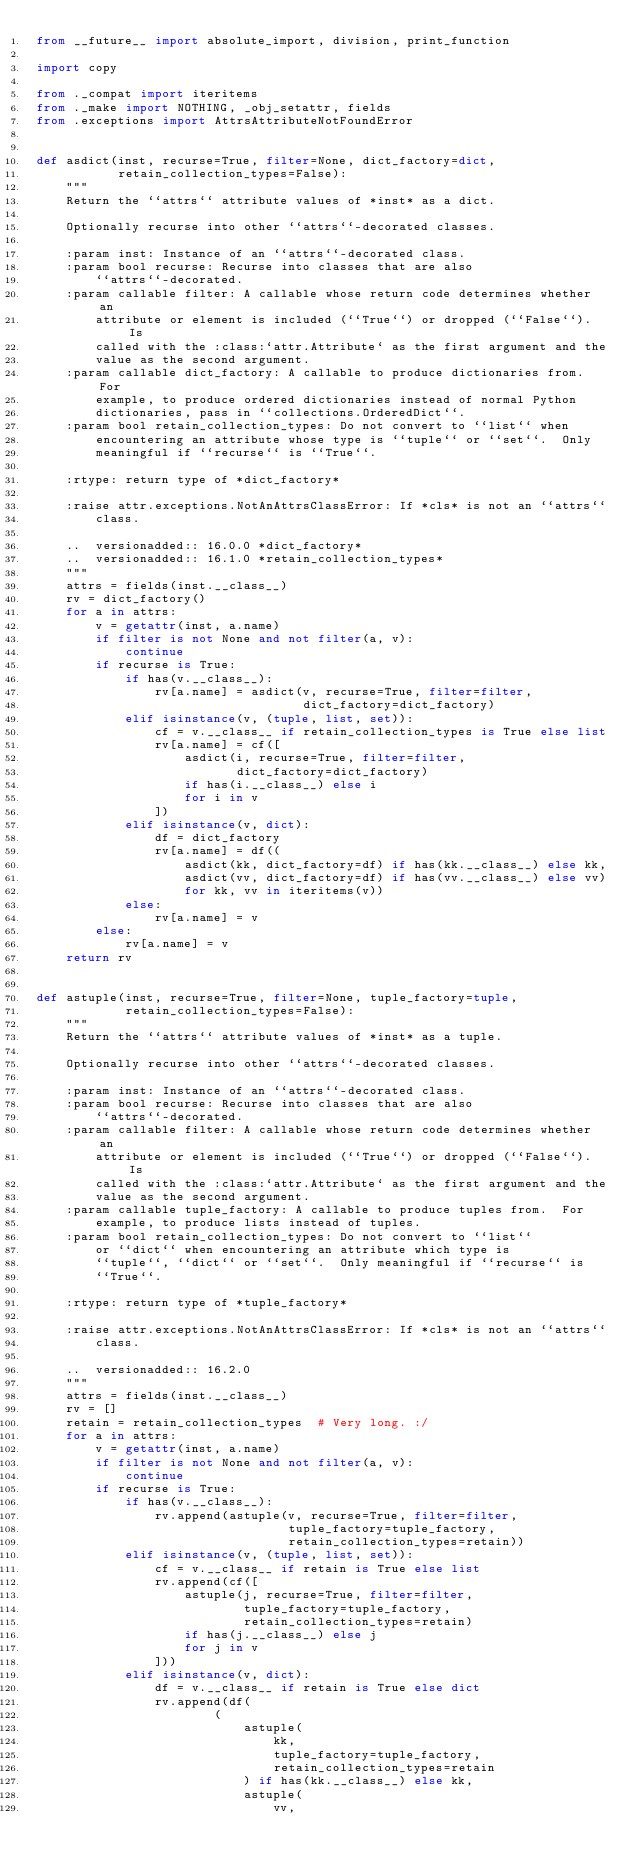<code> <loc_0><loc_0><loc_500><loc_500><_Python_>from __future__ import absolute_import, division, print_function

import copy

from ._compat import iteritems
from ._make import NOTHING, _obj_setattr, fields
from .exceptions import AttrsAttributeNotFoundError


def asdict(inst, recurse=True, filter=None, dict_factory=dict,
           retain_collection_types=False):
    """
    Return the ``attrs`` attribute values of *inst* as a dict.

    Optionally recurse into other ``attrs``-decorated classes.

    :param inst: Instance of an ``attrs``-decorated class.
    :param bool recurse: Recurse into classes that are also
        ``attrs``-decorated.
    :param callable filter: A callable whose return code determines whether an
        attribute or element is included (``True``) or dropped (``False``).  Is
        called with the :class:`attr.Attribute` as the first argument and the
        value as the second argument.
    :param callable dict_factory: A callable to produce dictionaries from.  For
        example, to produce ordered dictionaries instead of normal Python
        dictionaries, pass in ``collections.OrderedDict``.
    :param bool retain_collection_types: Do not convert to ``list`` when
        encountering an attribute whose type is ``tuple`` or ``set``.  Only
        meaningful if ``recurse`` is ``True``.

    :rtype: return type of *dict_factory*

    :raise attr.exceptions.NotAnAttrsClassError: If *cls* is not an ``attrs``
        class.

    ..  versionadded:: 16.0.0 *dict_factory*
    ..  versionadded:: 16.1.0 *retain_collection_types*
    """
    attrs = fields(inst.__class__)
    rv = dict_factory()
    for a in attrs:
        v = getattr(inst, a.name)
        if filter is not None and not filter(a, v):
            continue
        if recurse is True:
            if has(v.__class__):
                rv[a.name] = asdict(v, recurse=True, filter=filter,
                                    dict_factory=dict_factory)
            elif isinstance(v, (tuple, list, set)):
                cf = v.__class__ if retain_collection_types is True else list
                rv[a.name] = cf([
                    asdict(i, recurse=True, filter=filter,
                           dict_factory=dict_factory)
                    if has(i.__class__) else i
                    for i in v
                ])
            elif isinstance(v, dict):
                df = dict_factory
                rv[a.name] = df((
                    asdict(kk, dict_factory=df) if has(kk.__class__) else kk,
                    asdict(vv, dict_factory=df) if has(vv.__class__) else vv)
                    for kk, vv in iteritems(v))
            else:
                rv[a.name] = v
        else:
            rv[a.name] = v
    return rv


def astuple(inst, recurse=True, filter=None, tuple_factory=tuple,
            retain_collection_types=False):
    """
    Return the ``attrs`` attribute values of *inst* as a tuple.

    Optionally recurse into other ``attrs``-decorated classes.

    :param inst: Instance of an ``attrs``-decorated class.
    :param bool recurse: Recurse into classes that are also
        ``attrs``-decorated.
    :param callable filter: A callable whose return code determines whether an
        attribute or element is included (``True``) or dropped (``False``).  Is
        called with the :class:`attr.Attribute` as the first argument and the
        value as the second argument.
    :param callable tuple_factory: A callable to produce tuples from.  For
        example, to produce lists instead of tuples.
    :param bool retain_collection_types: Do not convert to ``list``
        or ``dict`` when encountering an attribute which type is
        ``tuple``, ``dict`` or ``set``.  Only meaningful if ``recurse`` is
        ``True``.

    :rtype: return type of *tuple_factory*

    :raise attr.exceptions.NotAnAttrsClassError: If *cls* is not an ``attrs``
        class.

    ..  versionadded:: 16.2.0
    """
    attrs = fields(inst.__class__)
    rv = []
    retain = retain_collection_types  # Very long. :/
    for a in attrs:
        v = getattr(inst, a.name)
        if filter is not None and not filter(a, v):
            continue
        if recurse is True:
            if has(v.__class__):
                rv.append(astuple(v, recurse=True, filter=filter,
                                  tuple_factory=tuple_factory,
                                  retain_collection_types=retain))
            elif isinstance(v, (tuple, list, set)):
                cf = v.__class__ if retain is True else list
                rv.append(cf([
                    astuple(j, recurse=True, filter=filter,
                            tuple_factory=tuple_factory,
                            retain_collection_types=retain)
                    if has(j.__class__) else j
                    for j in v
                ]))
            elif isinstance(v, dict):
                df = v.__class__ if retain is True else dict
                rv.append(df(
                        (
                            astuple(
                                kk,
                                tuple_factory=tuple_factory,
                                retain_collection_types=retain
                            ) if has(kk.__class__) else kk,
                            astuple(
                                vv,</code> 